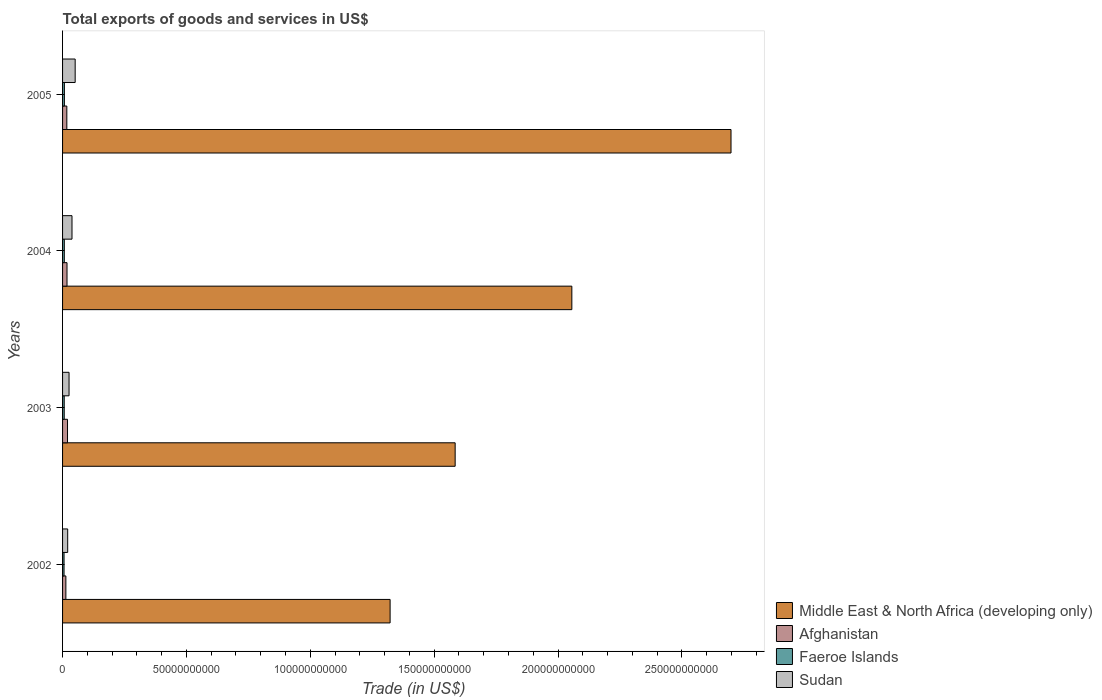How many groups of bars are there?
Your answer should be very brief. 4. How many bars are there on the 2nd tick from the top?
Ensure brevity in your answer.  4. What is the label of the 4th group of bars from the top?
Keep it short and to the point. 2002. What is the total exports of goods and services in Faeroe Islands in 2002?
Make the answer very short. 5.98e+08. Across all years, what is the maximum total exports of goods and services in Middle East & North Africa (developing only)?
Provide a short and direct response. 2.70e+11. Across all years, what is the minimum total exports of goods and services in Afghanistan?
Offer a terse response. 1.34e+09. What is the total total exports of goods and services in Faeroe Islands in the graph?
Offer a terse response. 2.71e+09. What is the difference between the total exports of goods and services in Middle East & North Africa (developing only) in 2002 and that in 2004?
Make the answer very short. -7.34e+1. What is the difference between the total exports of goods and services in Afghanistan in 2004 and the total exports of goods and services in Faeroe Islands in 2005?
Give a very brief answer. 1.06e+09. What is the average total exports of goods and services in Sudan per year?
Your answer should be very brief. 3.40e+09. In the year 2002, what is the difference between the total exports of goods and services in Afghanistan and total exports of goods and services in Faeroe Islands?
Offer a terse response. 7.39e+08. What is the ratio of the total exports of goods and services in Afghanistan in 2004 to that in 2005?
Provide a short and direct response. 1.05. Is the total exports of goods and services in Afghanistan in 2003 less than that in 2004?
Your answer should be very brief. No. What is the difference between the highest and the second highest total exports of goods and services in Middle East & North Africa (developing only)?
Your answer should be very brief. 6.42e+1. What is the difference between the highest and the lowest total exports of goods and services in Sudan?
Provide a short and direct response. 3.02e+09. In how many years, is the total exports of goods and services in Faeroe Islands greater than the average total exports of goods and services in Faeroe Islands taken over all years?
Make the answer very short. 2. Is the sum of the total exports of goods and services in Sudan in 2002 and 2005 greater than the maximum total exports of goods and services in Afghanistan across all years?
Your answer should be compact. Yes. What does the 4th bar from the top in 2004 represents?
Ensure brevity in your answer.  Middle East & North Africa (developing only). What does the 1st bar from the bottom in 2002 represents?
Your response must be concise. Middle East & North Africa (developing only). How many bars are there?
Your answer should be very brief. 16. Are all the bars in the graph horizontal?
Your answer should be compact. Yes. What is the difference between two consecutive major ticks on the X-axis?
Keep it short and to the point. 5.00e+1. Does the graph contain grids?
Your answer should be very brief. No. What is the title of the graph?
Ensure brevity in your answer.  Total exports of goods and services in US$. What is the label or title of the X-axis?
Keep it short and to the point. Trade (in US$). What is the Trade (in US$) of Middle East & North Africa (developing only) in 2002?
Your answer should be very brief. 1.32e+11. What is the Trade (in US$) in Afghanistan in 2002?
Offer a very short reply. 1.34e+09. What is the Trade (in US$) of Faeroe Islands in 2002?
Your answer should be compact. 5.98e+08. What is the Trade (in US$) of Sudan in 2002?
Your answer should be compact. 2.07e+09. What is the Trade (in US$) in Middle East & North Africa (developing only) in 2003?
Make the answer very short. 1.58e+11. What is the Trade (in US$) of Afghanistan in 2003?
Your response must be concise. 2.00e+09. What is the Trade (in US$) of Faeroe Islands in 2003?
Ensure brevity in your answer.  6.68e+08. What is the Trade (in US$) of Sudan in 2003?
Provide a short and direct response. 2.62e+09. What is the Trade (in US$) in Middle East & North Africa (developing only) in 2004?
Offer a terse response. 2.06e+11. What is the Trade (in US$) of Afghanistan in 2004?
Ensure brevity in your answer.  1.80e+09. What is the Trade (in US$) of Faeroe Islands in 2004?
Your answer should be very brief. 7.05e+08. What is the Trade (in US$) in Sudan in 2004?
Provide a short and direct response. 3.81e+09. What is the Trade (in US$) in Middle East & North Africa (developing only) in 2005?
Ensure brevity in your answer.  2.70e+11. What is the Trade (in US$) of Afghanistan in 2005?
Ensure brevity in your answer.  1.72e+09. What is the Trade (in US$) of Faeroe Islands in 2005?
Your answer should be very brief. 7.36e+08. What is the Trade (in US$) of Sudan in 2005?
Your response must be concise. 5.09e+09. Across all years, what is the maximum Trade (in US$) in Middle East & North Africa (developing only)?
Your response must be concise. 2.70e+11. Across all years, what is the maximum Trade (in US$) of Afghanistan?
Provide a succinct answer. 2.00e+09. Across all years, what is the maximum Trade (in US$) of Faeroe Islands?
Ensure brevity in your answer.  7.36e+08. Across all years, what is the maximum Trade (in US$) of Sudan?
Provide a short and direct response. 5.09e+09. Across all years, what is the minimum Trade (in US$) of Middle East & North Africa (developing only)?
Offer a very short reply. 1.32e+11. Across all years, what is the minimum Trade (in US$) in Afghanistan?
Your response must be concise. 1.34e+09. Across all years, what is the minimum Trade (in US$) of Faeroe Islands?
Your response must be concise. 5.98e+08. Across all years, what is the minimum Trade (in US$) in Sudan?
Give a very brief answer. 2.07e+09. What is the total Trade (in US$) in Middle East & North Africa (developing only) in the graph?
Offer a terse response. 7.66e+11. What is the total Trade (in US$) in Afghanistan in the graph?
Keep it short and to the point. 6.85e+09. What is the total Trade (in US$) of Faeroe Islands in the graph?
Provide a succinct answer. 2.71e+09. What is the total Trade (in US$) of Sudan in the graph?
Offer a very short reply. 1.36e+1. What is the difference between the Trade (in US$) of Middle East & North Africa (developing only) in 2002 and that in 2003?
Make the answer very short. -2.63e+1. What is the difference between the Trade (in US$) of Afghanistan in 2002 and that in 2003?
Provide a short and direct response. -6.59e+08. What is the difference between the Trade (in US$) in Faeroe Islands in 2002 and that in 2003?
Make the answer very short. -6.99e+07. What is the difference between the Trade (in US$) in Sudan in 2002 and that in 2003?
Give a very brief answer. -5.47e+08. What is the difference between the Trade (in US$) in Middle East & North Africa (developing only) in 2002 and that in 2004?
Offer a very short reply. -7.34e+1. What is the difference between the Trade (in US$) of Afghanistan in 2002 and that in 2004?
Your answer should be compact. -4.60e+08. What is the difference between the Trade (in US$) in Faeroe Islands in 2002 and that in 2004?
Offer a terse response. -1.07e+08. What is the difference between the Trade (in US$) in Sudan in 2002 and that in 2004?
Your response must be concise. -1.74e+09. What is the difference between the Trade (in US$) in Middle East & North Africa (developing only) in 2002 and that in 2005?
Ensure brevity in your answer.  -1.38e+11. What is the difference between the Trade (in US$) of Afghanistan in 2002 and that in 2005?
Offer a very short reply. -3.82e+08. What is the difference between the Trade (in US$) of Faeroe Islands in 2002 and that in 2005?
Your answer should be compact. -1.38e+08. What is the difference between the Trade (in US$) in Sudan in 2002 and that in 2005?
Provide a succinct answer. -3.02e+09. What is the difference between the Trade (in US$) of Middle East & North Africa (developing only) in 2003 and that in 2004?
Give a very brief answer. -4.71e+1. What is the difference between the Trade (in US$) of Afghanistan in 2003 and that in 2004?
Offer a terse response. 2.00e+08. What is the difference between the Trade (in US$) of Faeroe Islands in 2003 and that in 2004?
Provide a succinct answer. -3.74e+07. What is the difference between the Trade (in US$) of Sudan in 2003 and that in 2004?
Your answer should be very brief. -1.19e+09. What is the difference between the Trade (in US$) in Middle East & North Africa (developing only) in 2003 and that in 2005?
Ensure brevity in your answer.  -1.11e+11. What is the difference between the Trade (in US$) of Afghanistan in 2003 and that in 2005?
Give a very brief answer. 2.77e+08. What is the difference between the Trade (in US$) in Faeroe Islands in 2003 and that in 2005?
Keep it short and to the point. -6.81e+07. What is the difference between the Trade (in US$) of Sudan in 2003 and that in 2005?
Your response must be concise. -2.47e+09. What is the difference between the Trade (in US$) of Middle East & North Africa (developing only) in 2004 and that in 2005?
Give a very brief answer. -6.42e+1. What is the difference between the Trade (in US$) in Afghanistan in 2004 and that in 2005?
Give a very brief answer. 7.78e+07. What is the difference between the Trade (in US$) of Faeroe Islands in 2004 and that in 2005?
Provide a succinct answer. -3.07e+07. What is the difference between the Trade (in US$) of Sudan in 2004 and that in 2005?
Your answer should be compact. -1.28e+09. What is the difference between the Trade (in US$) in Middle East & North Africa (developing only) in 2002 and the Trade (in US$) in Afghanistan in 2003?
Make the answer very short. 1.30e+11. What is the difference between the Trade (in US$) of Middle East & North Africa (developing only) in 2002 and the Trade (in US$) of Faeroe Islands in 2003?
Make the answer very short. 1.32e+11. What is the difference between the Trade (in US$) in Middle East & North Africa (developing only) in 2002 and the Trade (in US$) in Sudan in 2003?
Your answer should be compact. 1.30e+11. What is the difference between the Trade (in US$) in Afghanistan in 2002 and the Trade (in US$) in Faeroe Islands in 2003?
Offer a terse response. 6.70e+08. What is the difference between the Trade (in US$) in Afghanistan in 2002 and the Trade (in US$) in Sudan in 2003?
Your answer should be compact. -1.28e+09. What is the difference between the Trade (in US$) in Faeroe Islands in 2002 and the Trade (in US$) in Sudan in 2003?
Your answer should be compact. -2.02e+09. What is the difference between the Trade (in US$) in Middle East & North Africa (developing only) in 2002 and the Trade (in US$) in Afghanistan in 2004?
Your answer should be compact. 1.30e+11. What is the difference between the Trade (in US$) in Middle East & North Africa (developing only) in 2002 and the Trade (in US$) in Faeroe Islands in 2004?
Offer a terse response. 1.32e+11. What is the difference between the Trade (in US$) of Middle East & North Africa (developing only) in 2002 and the Trade (in US$) of Sudan in 2004?
Ensure brevity in your answer.  1.28e+11. What is the difference between the Trade (in US$) of Afghanistan in 2002 and the Trade (in US$) of Faeroe Islands in 2004?
Offer a very short reply. 6.32e+08. What is the difference between the Trade (in US$) in Afghanistan in 2002 and the Trade (in US$) in Sudan in 2004?
Make the answer very short. -2.47e+09. What is the difference between the Trade (in US$) of Faeroe Islands in 2002 and the Trade (in US$) of Sudan in 2004?
Your answer should be compact. -3.21e+09. What is the difference between the Trade (in US$) of Middle East & North Africa (developing only) in 2002 and the Trade (in US$) of Afghanistan in 2005?
Offer a very short reply. 1.30e+11. What is the difference between the Trade (in US$) in Middle East & North Africa (developing only) in 2002 and the Trade (in US$) in Faeroe Islands in 2005?
Ensure brevity in your answer.  1.31e+11. What is the difference between the Trade (in US$) in Middle East & North Africa (developing only) in 2002 and the Trade (in US$) in Sudan in 2005?
Offer a very short reply. 1.27e+11. What is the difference between the Trade (in US$) of Afghanistan in 2002 and the Trade (in US$) of Faeroe Islands in 2005?
Your response must be concise. 6.01e+08. What is the difference between the Trade (in US$) of Afghanistan in 2002 and the Trade (in US$) of Sudan in 2005?
Offer a terse response. -3.75e+09. What is the difference between the Trade (in US$) of Faeroe Islands in 2002 and the Trade (in US$) of Sudan in 2005?
Your response must be concise. -4.49e+09. What is the difference between the Trade (in US$) of Middle East & North Africa (developing only) in 2003 and the Trade (in US$) of Afghanistan in 2004?
Offer a very short reply. 1.57e+11. What is the difference between the Trade (in US$) in Middle East & North Africa (developing only) in 2003 and the Trade (in US$) in Faeroe Islands in 2004?
Make the answer very short. 1.58e+11. What is the difference between the Trade (in US$) in Middle East & North Africa (developing only) in 2003 and the Trade (in US$) in Sudan in 2004?
Your response must be concise. 1.55e+11. What is the difference between the Trade (in US$) of Afghanistan in 2003 and the Trade (in US$) of Faeroe Islands in 2004?
Provide a short and direct response. 1.29e+09. What is the difference between the Trade (in US$) of Afghanistan in 2003 and the Trade (in US$) of Sudan in 2004?
Ensure brevity in your answer.  -1.81e+09. What is the difference between the Trade (in US$) in Faeroe Islands in 2003 and the Trade (in US$) in Sudan in 2004?
Offer a terse response. -3.14e+09. What is the difference between the Trade (in US$) in Middle East & North Africa (developing only) in 2003 and the Trade (in US$) in Afghanistan in 2005?
Ensure brevity in your answer.  1.57e+11. What is the difference between the Trade (in US$) of Middle East & North Africa (developing only) in 2003 and the Trade (in US$) of Faeroe Islands in 2005?
Give a very brief answer. 1.58e+11. What is the difference between the Trade (in US$) of Middle East & North Africa (developing only) in 2003 and the Trade (in US$) of Sudan in 2005?
Make the answer very short. 1.53e+11. What is the difference between the Trade (in US$) of Afghanistan in 2003 and the Trade (in US$) of Faeroe Islands in 2005?
Provide a succinct answer. 1.26e+09. What is the difference between the Trade (in US$) of Afghanistan in 2003 and the Trade (in US$) of Sudan in 2005?
Ensure brevity in your answer.  -3.09e+09. What is the difference between the Trade (in US$) in Faeroe Islands in 2003 and the Trade (in US$) in Sudan in 2005?
Your answer should be compact. -4.42e+09. What is the difference between the Trade (in US$) of Middle East & North Africa (developing only) in 2004 and the Trade (in US$) of Afghanistan in 2005?
Make the answer very short. 2.04e+11. What is the difference between the Trade (in US$) of Middle East & North Africa (developing only) in 2004 and the Trade (in US$) of Faeroe Islands in 2005?
Offer a terse response. 2.05e+11. What is the difference between the Trade (in US$) of Middle East & North Africa (developing only) in 2004 and the Trade (in US$) of Sudan in 2005?
Your answer should be compact. 2.00e+11. What is the difference between the Trade (in US$) of Afghanistan in 2004 and the Trade (in US$) of Faeroe Islands in 2005?
Your response must be concise. 1.06e+09. What is the difference between the Trade (in US$) in Afghanistan in 2004 and the Trade (in US$) in Sudan in 2005?
Keep it short and to the point. -3.29e+09. What is the difference between the Trade (in US$) of Faeroe Islands in 2004 and the Trade (in US$) of Sudan in 2005?
Offer a terse response. -4.38e+09. What is the average Trade (in US$) of Middle East & North Africa (developing only) per year?
Ensure brevity in your answer.  1.92e+11. What is the average Trade (in US$) of Afghanistan per year?
Your response must be concise. 1.71e+09. What is the average Trade (in US$) in Faeroe Islands per year?
Your answer should be very brief. 6.77e+08. What is the average Trade (in US$) of Sudan per year?
Your answer should be very brief. 3.40e+09. In the year 2002, what is the difference between the Trade (in US$) of Middle East & North Africa (developing only) and Trade (in US$) of Afghanistan?
Provide a succinct answer. 1.31e+11. In the year 2002, what is the difference between the Trade (in US$) in Middle East & North Africa (developing only) and Trade (in US$) in Faeroe Islands?
Offer a very short reply. 1.32e+11. In the year 2002, what is the difference between the Trade (in US$) in Middle East & North Africa (developing only) and Trade (in US$) in Sudan?
Give a very brief answer. 1.30e+11. In the year 2002, what is the difference between the Trade (in US$) in Afghanistan and Trade (in US$) in Faeroe Islands?
Provide a succinct answer. 7.39e+08. In the year 2002, what is the difference between the Trade (in US$) in Afghanistan and Trade (in US$) in Sudan?
Ensure brevity in your answer.  -7.32e+08. In the year 2002, what is the difference between the Trade (in US$) in Faeroe Islands and Trade (in US$) in Sudan?
Offer a very short reply. -1.47e+09. In the year 2003, what is the difference between the Trade (in US$) in Middle East & North Africa (developing only) and Trade (in US$) in Afghanistan?
Ensure brevity in your answer.  1.56e+11. In the year 2003, what is the difference between the Trade (in US$) of Middle East & North Africa (developing only) and Trade (in US$) of Faeroe Islands?
Your response must be concise. 1.58e+11. In the year 2003, what is the difference between the Trade (in US$) in Middle East & North Africa (developing only) and Trade (in US$) in Sudan?
Your answer should be very brief. 1.56e+11. In the year 2003, what is the difference between the Trade (in US$) in Afghanistan and Trade (in US$) in Faeroe Islands?
Keep it short and to the point. 1.33e+09. In the year 2003, what is the difference between the Trade (in US$) of Afghanistan and Trade (in US$) of Sudan?
Provide a short and direct response. -6.20e+08. In the year 2003, what is the difference between the Trade (in US$) in Faeroe Islands and Trade (in US$) in Sudan?
Ensure brevity in your answer.  -1.95e+09. In the year 2004, what is the difference between the Trade (in US$) of Middle East & North Africa (developing only) and Trade (in US$) of Afghanistan?
Your response must be concise. 2.04e+11. In the year 2004, what is the difference between the Trade (in US$) of Middle East & North Africa (developing only) and Trade (in US$) of Faeroe Islands?
Your response must be concise. 2.05e+11. In the year 2004, what is the difference between the Trade (in US$) in Middle East & North Africa (developing only) and Trade (in US$) in Sudan?
Give a very brief answer. 2.02e+11. In the year 2004, what is the difference between the Trade (in US$) of Afghanistan and Trade (in US$) of Faeroe Islands?
Offer a terse response. 1.09e+09. In the year 2004, what is the difference between the Trade (in US$) of Afghanistan and Trade (in US$) of Sudan?
Offer a terse response. -2.01e+09. In the year 2004, what is the difference between the Trade (in US$) of Faeroe Islands and Trade (in US$) of Sudan?
Make the answer very short. -3.11e+09. In the year 2005, what is the difference between the Trade (in US$) in Middle East & North Africa (developing only) and Trade (in US$) in Afghanistan?
Ensure brevity in your answer.  2.68e+11. In the year 2005, what is the difference between the Trade (in US$) of Middle East & North Africa (developing only) and Trade (in US$) of Faeroe Islands?
Keep it short and to the point. 2.69e+11. In the year 2005, what is the difference between the Trade (in US$) of Middle East & North Africa (developing only) and Trade (in US$) of Sudan?
Offer a terse response. 2.65e+11. In the year 2005, what is the difference between the Trade (in US$) in Afghanistan and Trade (in US$) in Faeroe Islands?
Make the answer very short. 9.83e+08. In the year 2005, what is the difference between the Trade (in US$) in Afghanistan and Trade (in US$) in Sudan?
Offer a terse response. -3.37e+09. In the year 2005, what is the difference between the Trade (in US$) of Faeroe Islands and Trade (in US$) of Sudan?
Your response must be concise. -4.35e+09. What is the ratio of the Trade (in US$) of Middle East & North Africa (developing only) in 2002 to that in 2003?
Give a very brief answer. 0.83. What is the ratio of the Trade (in US$) in Afghanistan in 2002 to that in 2003?
Your answer should be very brief. 0.67. What is the ratio of the Trade (in US$) in Faeroe Islands in 2002 to that in 2003?
Keep it short and to the point. 0.9. What is the ratio of the Trade (in US$) of Sudan in 2002 to that in 2003?
Offer a very short reply. 0.79. What is the ratio of the Trade (in US$) in Middle East & North Africa (developing only) in 2002 to that in 2004?
Make the answer very short. 0.64. What is the ratio of the Trade (in US$) in Afghanistan in 2002 to that in 2004?
Provide a short and direct response. 0.74. What is the ratio of the Trade (in US$) of Faeroe Islands in 2002 to that in 2004?
Provide a short and direct response. 0.85. What is the ratio of the Trade (in US$) of Sudan in 2002 to that in 2004?
Keep it short and to the point. 0.54. What is the ratio of the Trade (in US$) in Middle East & North Africa (developing only) in 2002 to that in 2005?
Keep it short and to the point. 0.49. What is the ratio of the Trade (in US$) of Afghanistan in 2002 to that in 2005?
Keep it short and to the point. 0.78. What is the ratio of the Trade (in US$) of Faeroe Islands in 2002 to that in 2005?
Give a very brief answer. 0.81. What is the ratio of the Trade (in US$) in Sudan in 2002 to that in 2005?
Give a very brief answer. 0.41. What is the ratio of the Trade (in US$) in Middle East & North Africa (developing only) in 2003 to that in 2004?
Give a very brief answer. 0.77. What is the ratio of the Trade (in US$) of Faeroe Islands in 2003 to that in 2004?
Ensure brevity in your answer.  0.95. What is the ratio of the Trade (in US$) of Sudan in 2003 to that in 2004?
Your answer should be very brief. 0.69. What is the ratio of the Trade (in US$) in Middle East & North Africa (developing only) in 2003 to that in 2005?
Your response must be concise. 0.59. What is the ratio of the Trade (in US$) of Afghanistan in 2003 to that in 2005?
Offer a terse response. 1.16. What is the ratio of the Trade (in US$) in Faeroe Islands in 2003 to that in 2005?
Offer a very short reply. 0.91. What is the ratio of the Trade (in US$) of Sudan in 2003 to that in 2005?
Offer a terse response. 0.51. What is the ratio of the Trade (in US$) in Middle East & North Africa (developing only) in 2004 to that in 2005?
Make the answer very short. 0.76. What is the ratio of the Trade (in US$) of Afghanistan in 2004 to that in 2005?
Offer a very short reply. 1.05. What is the ratio of the Trade (in US$) in Sudan in 2004 to that in 2005?
Your answer should be compact. 0.75. What is the difference between the highest and the second highest Trade (in US$) in Middle East & North Africa (developing only)?
Keep it short and to the point. 6.42e+1. What is the difference between the highest and the second highest Trade (in US$) in Afghanistan?
Offer a terse response. 2.00e+08. What is the difference between the highest and the second highest Trade (in US$) in Faeroe Islands?
Provide a short and direct response. 3.07e+07. What is the difference between the highest and the second highest Trade (in US$) of Sudan?
Provide a short and direct response. 1.28e+09. What is the difference between the highest and the lowest Trade (in US$) in Middle East & North Africa (developing only)?
Offer a terse response. 1.38e+11. What is the difference between the highest and the lowest Trade (in US$) of Afghanistan?
Your answer should be compact. 6.59e+08. What is the difference between the highest and the lowest Trade (in US$) in Faeroe Islands?
Make the answer very short. 1.38e+08. What is the difference between the highest and the lowest Trade (in US$) of Sudan?
Make the answer very short. 3.02e+09. 